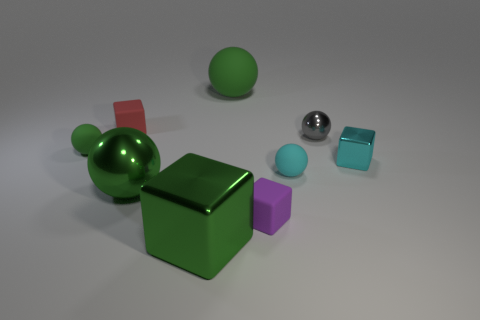What textures are visible among the objects in the image? The objects exhibit a variety of textures. The spheres and cube in the foreground have smooth, seemingly polished surfaces that reflect the light, giving them a shiny appearance. The cube on the back left, as well as the two smaller cubes, have matte surfaces that do not reflect light to the same extent, resulting in a softer, non-glossy look. 